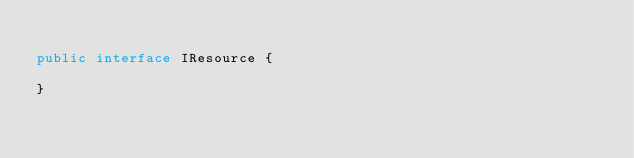<code> <loc_0><loc_0><loc_500><loc_500><_Java_>
public interface IResource {

}
</code> 